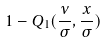Convert formula to latex. <formula><loc_0><loc_0><loc_500><loc_500>1 - Q _ { 1 } ( \frac { \nu } { \sigma } , \frac { x } { \sigma } )</formula> 